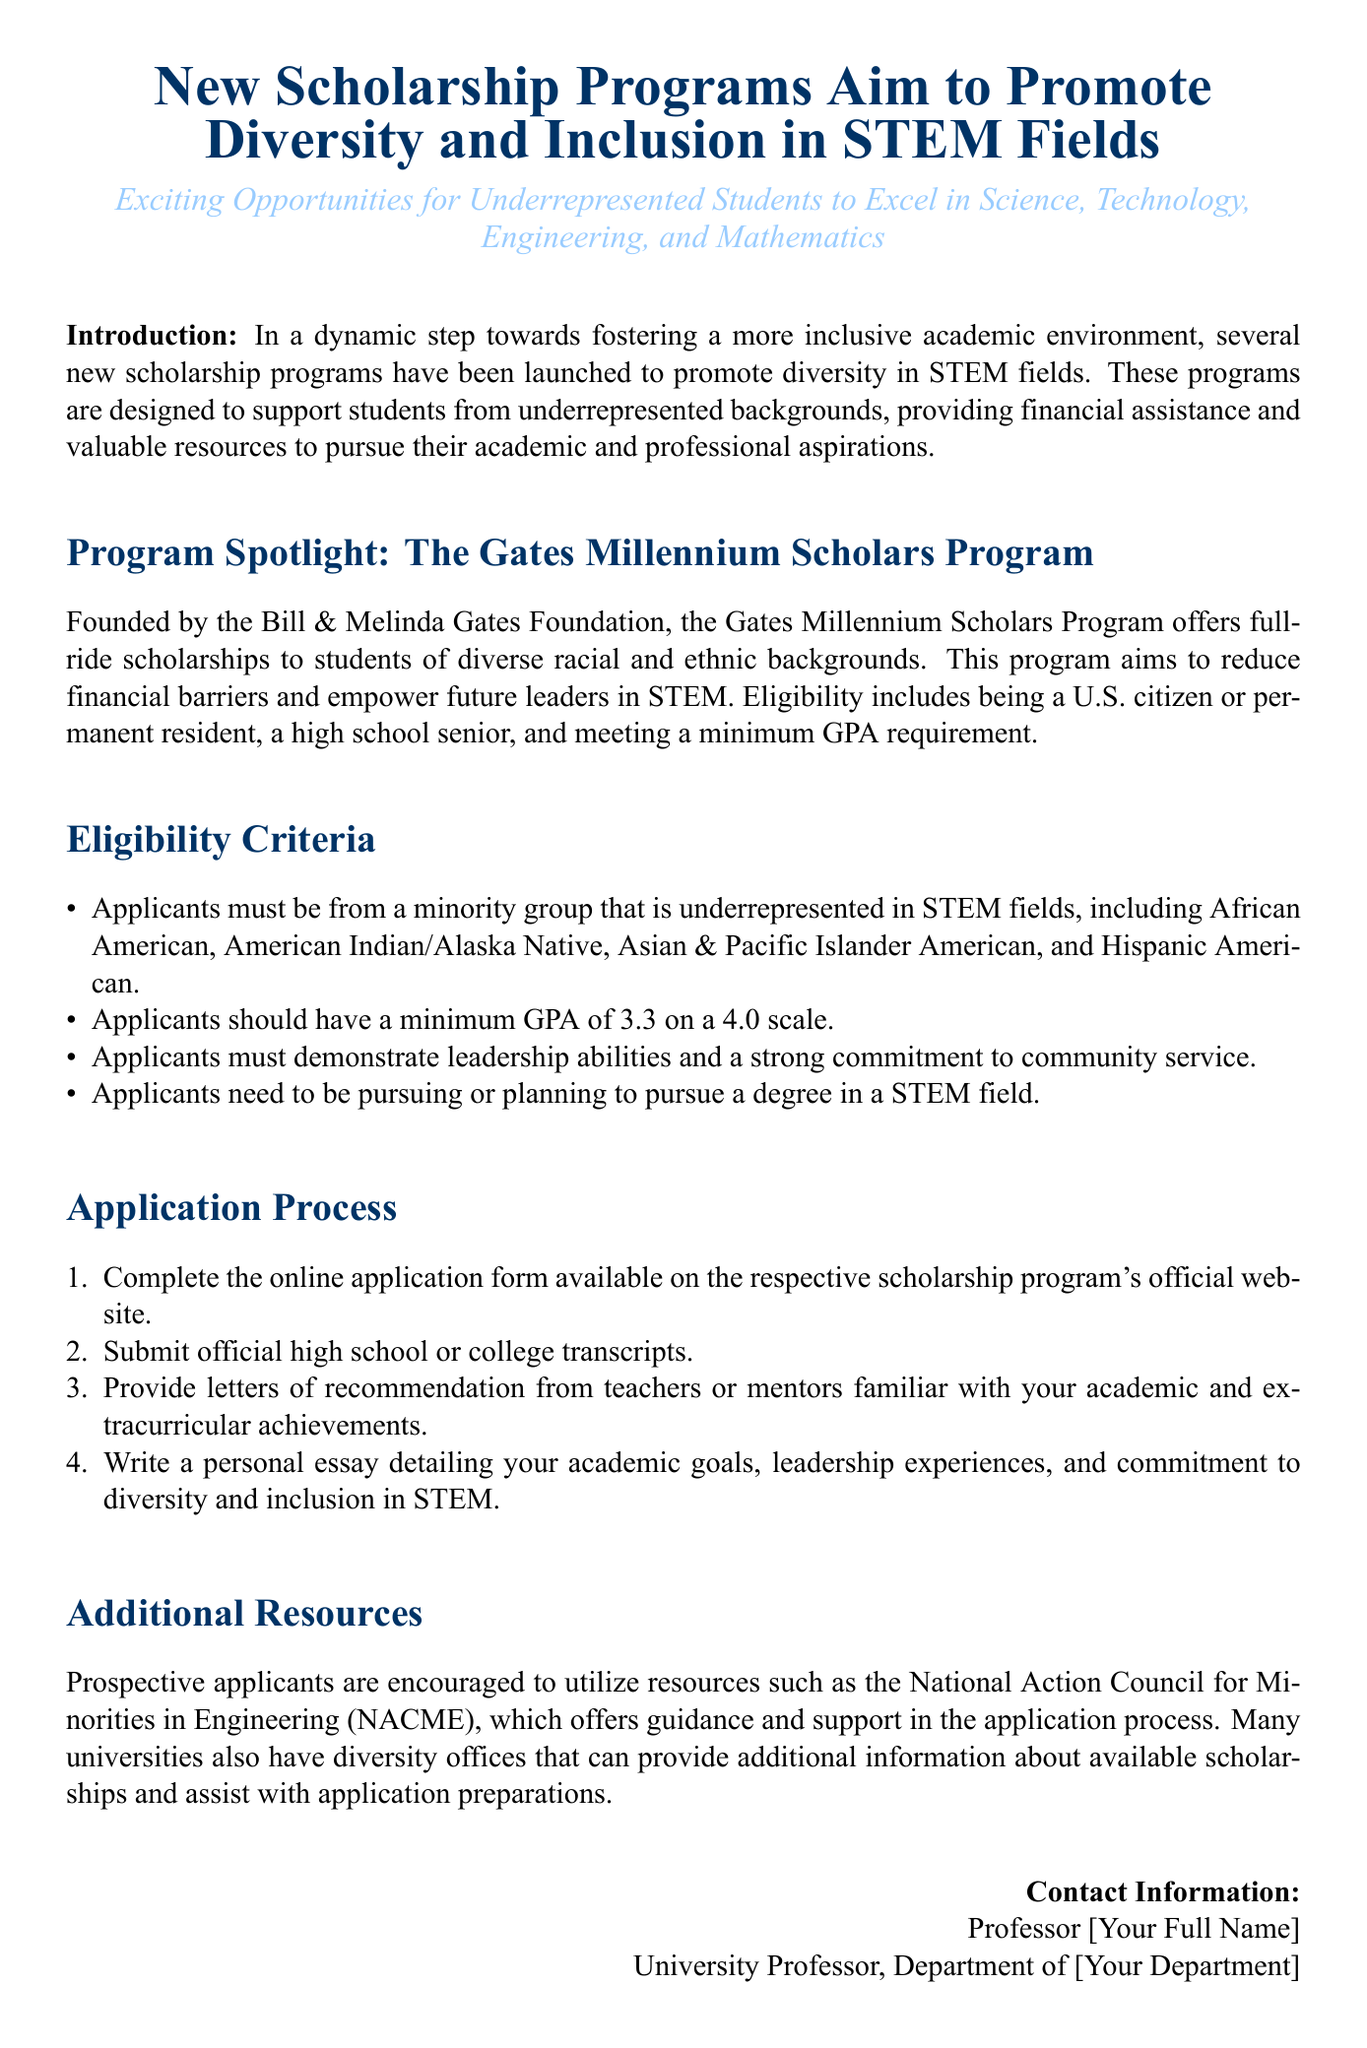What is the name of the scholarship program founded by the Bill & Melinda Gates Foundation? The scholarship program is designed to support students and reduce financial barriers in STEM fields, and is called the Gates Millennium Scholars Program.
Answer: Gates Millennium Scholars Program What is the minimum GPA requirement for applicants? The document specifies that applicants must have a minimum GPA on a 4.0 scale to be eligible for the scholarship program.
Answer: 3.3 Who can apply for the scholarship? The scholarship is aimed at students from minority groups that are underrepresented in STEM, which includes specific racial and ethnic categories outlined in the document.
Answer: Minority groups What type of essay must applicants write? The application process requires a personal essay detailing specific aspects of the applicants' experiences and goals related to diversity.
Answer: Personal essay Which organization's resources are recommended for prospective applicants? The document mentions an organization dedicated to minorities in engineering that can help with the application process.
Answer: National Action Council for Minorities in Engineering How many steps are outlined in the application process? The document lists a sequence of actions required for the application process, indicating the organization and thoroughness of the steps.
Answer: Four steps What is the primary focus of the new scholarship programs? The scholarships are designed to enhance opportunities in academia for specific underserved groups in a critical area of study.
Answer: Diversity and Inclusion in STEM What type of students are these scholarship programs specifically targeting? The scholarship programs aim to provide assistance to students facing financial obstacles and are typically underrepresented in specific fields.
Answer: Underrepresented students 